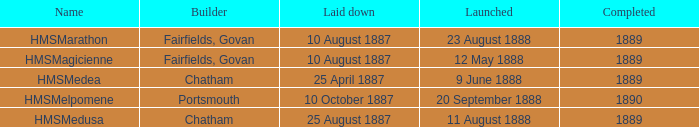What watercraft was initiated on 25 april 1887? HMSMedea. 